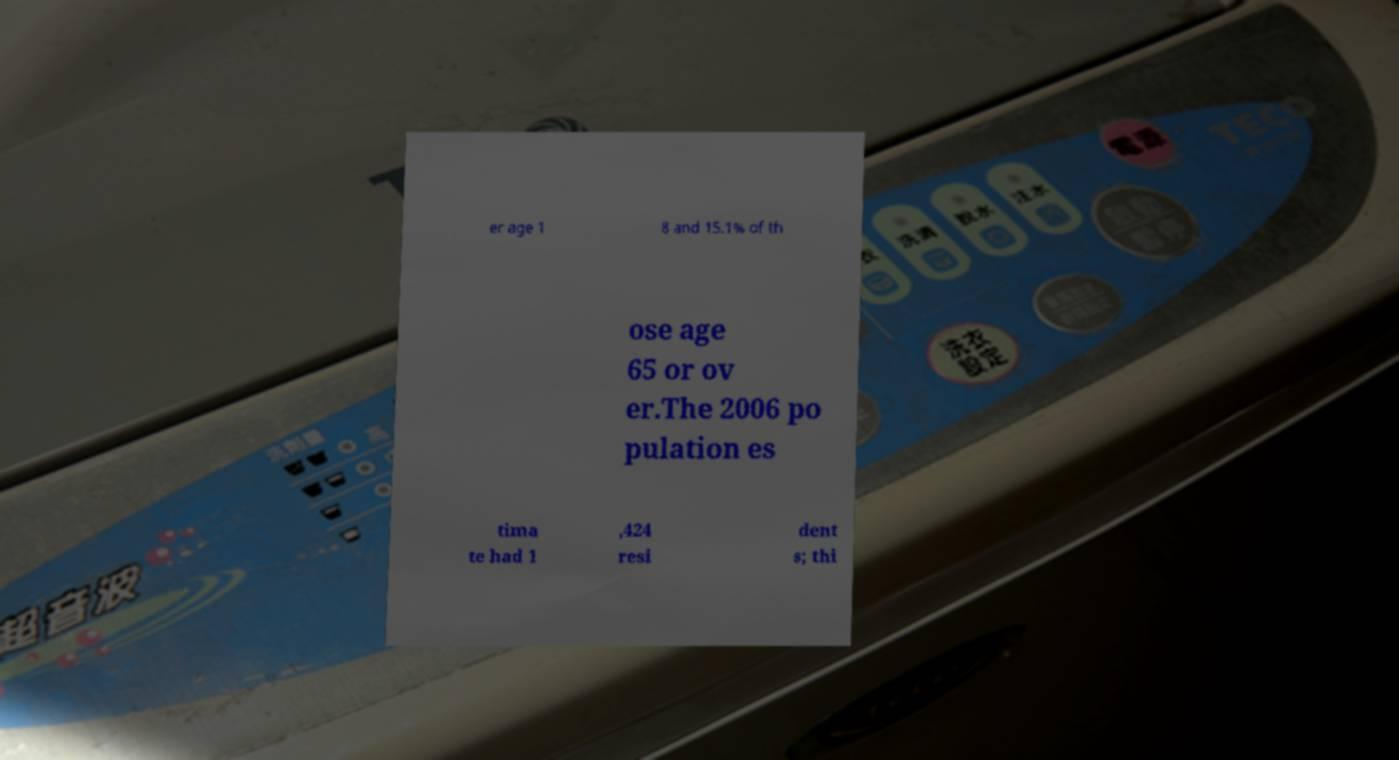Please identify and transcribe the text found in this image. er age 1 8 and 15.1% of th ose age 65 or ov er.The 2006 po pulation es tima te had 1 ,424 resi dent s; thi 